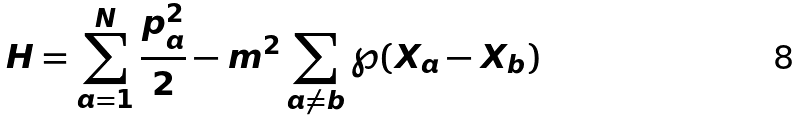Convert formula to latex. <formula><loc_0><loc_0><loc_500><loc_500>H = \sum _ { a = 1 } ^ { N } \frac { p _ { a } ^ { 2 } } { 2 } - m ^ { 2 } \sum _ { a \neq b } \wp ( X _ { a } - X _ { b } )</formula> 